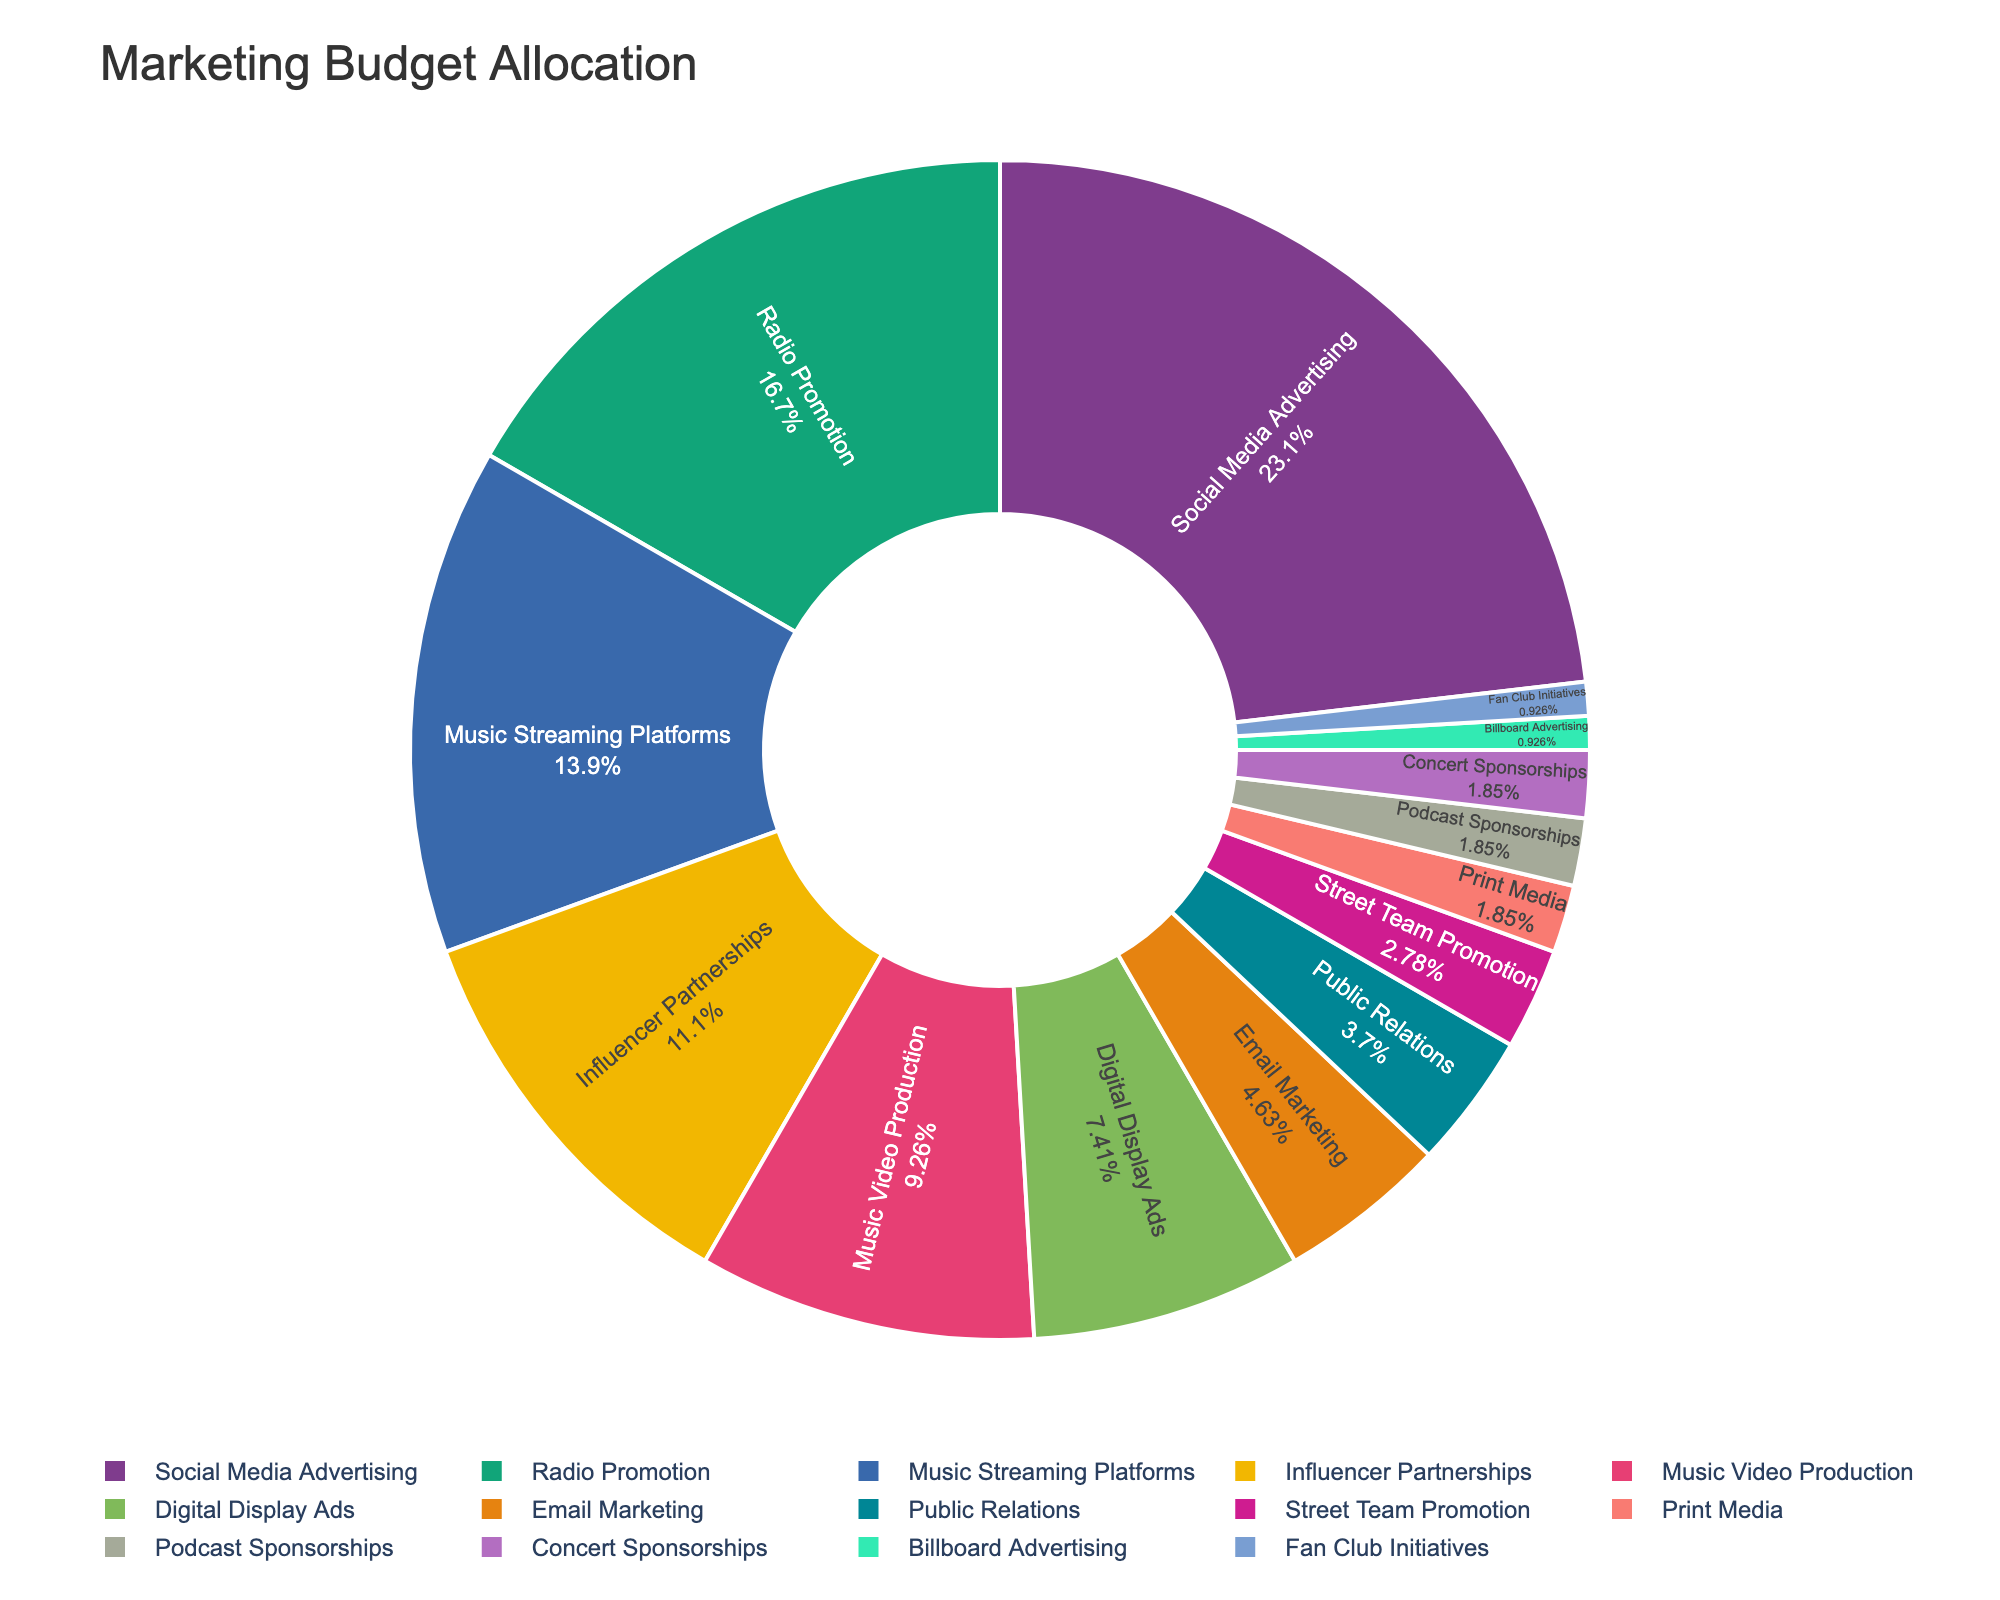What percentage of the budget is allocated to the top three channels? The top three channels by budget percentage are Social Media Advertising (25%), Radio Promotion (18%), and Music Streaming Platforms (15%). Summing these percentages: 25% + 18% + 15% = 58%
Answer: 58% Which channel receives the smallest share of the budget? The channels with the smallest shares of the budget are Billboard Advertising, Fan Club Initiatives, Print Media, Podcast Sponsorships, and Concert Sponsorships, each receiving 1%.
Answer: Billboard Advertising and Fan Club Initiatives How much more budget does Social Media Advertising receive compared to Influencer Partnerships? Social Media Advertising receives 25% of the budget, while Influencer Partnerships receive 12%. The difference is 25% - 12% = 13%.
Answer: 13% Which channels together make up more than half of the total budget? The channels are summed in descending order until they surpass 50%. Social Media Advertising (25%) + Radio Promotion (18%) + Music Streaming Platforms (15%) = 58%. Three channels, Social Media Advertising, Radio Promotion, and Music Streaming Platforms, make up more than 50% of the budget.
Answer: Social Media Advertising, Radio Promotion, Music Streaming Platforms Are there more channels with a budget allocation greater than or equal to 10% or less than 10%? There are five channels with a budget allocation of 10% or more: Social Media Advertising, Radio Promotion, Music Streaming Platforms, Influencer Partnerships, and Music Video Production. There are nine channels with a budget allocation of less than 10%.
Answer: Less than 10% What is the combined budget percentage for Digital Display Ads and Email Marketing? Digital Display Ads receive 8% of the budget, and Email Marketing receives 5%. Combined, this is 8% + 5% = 13%.
Answer: 13% Which is the largest channel whose budget allocation is in single digits? The channels with single-digit budget allocations are Digital Display Ads (8%), Email Marketing (5%), Public Relations (4%), Street Team Promotion (3%), Print Media (2%), Podcast Sponsorships (2%), Concert Sponsorships (2%), Billboard Advertising (1%), and Fan Club Initiatives (1%). The largest among these is Digital Display Ads with 8%.
Answer: Digital Display Ads How many channels receive exactly the same percentage of the budget? The channels Print Media, Podcast Sponsorships, and Concert Sponsorships each receive 2%. The channels Billboard Advertising and Fan Club Initiatives each receive 1%.
Answer: Five What is the average budget percentage allocated to channels with less than 5% of the total budget? Channels with less than 5% of the budget are Public Relations (4%), Street Team Promotion (3%), Print Media (2%), Podcast Sponsorships (2%), Concert Sponsorships (2%), Billboard Advertising (1%), and Fan Club Initiatives (1%). Their total percentage is 4% + 3% + 2% + 2% + 2% + 1% + 1% = 15%, and there are 7 channels. The average is 15% / 7 ≈ 2.14%.
Answer: 2.14% 